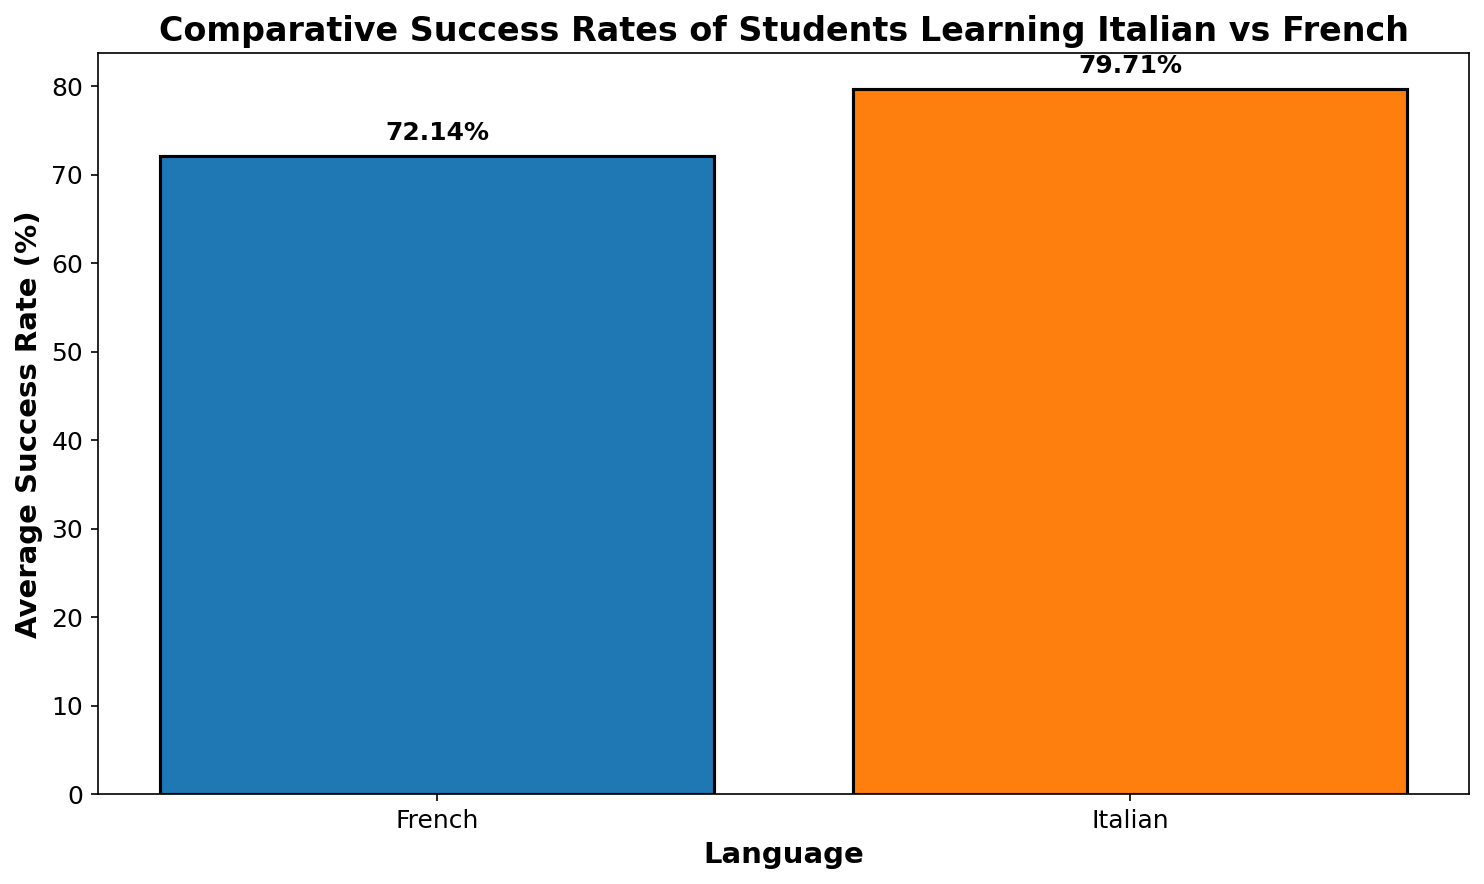Which language has a higher average success rate? Comparing the average success rates of Italian and French shown on the bar chart, Italian has the higher average success rate.
Answer: Italian What is the approximate difference between the average success rates of Italian and French? The average success rate for Italian is around 78.29%, and for French, it's approximately 71.50%. Subtracting the French rate from the Italian rate gives us the difference, 78.29% - 71.50%.
Answer: 6.79% Which bar is taller, the one for Italian or the one for French? The bar representing Italian is taller than the one representing French, indicating a higher average success rate.
Answer: The one for Italian How many percentage points higher is the Italian success rate compared to the French success rate? The Italian success rate is approximately 78.29%, and the French success rate is around 71.50%. The difference in percentage points is 78.29% - 71.50%.
Answer: 6.79 percentage points What visual element is used to indicate the success rate value on top of each bar? The bars have text annotations placed above them showing the specific success rate values.
Answer: Text annotations If a new language learning program aims to surpass the higher of these two current figures, what should be their target success rate? The highest average success rate displayed is for Italian at approximately 78.29%. Therefore, the new program should aim to have an average success rate higher than 78.29% to surpass it.
Answer: More than 78.29% By how many percentage points should a program’s success rate exceed the current lower rate to equal the higher rate? The success rate for French is lower at about 71.50%. To match the Italian success rate of approximately 78.29%, it needs to increase by 78.29% - 71.50%.
Answer: 6.79 percentage points 